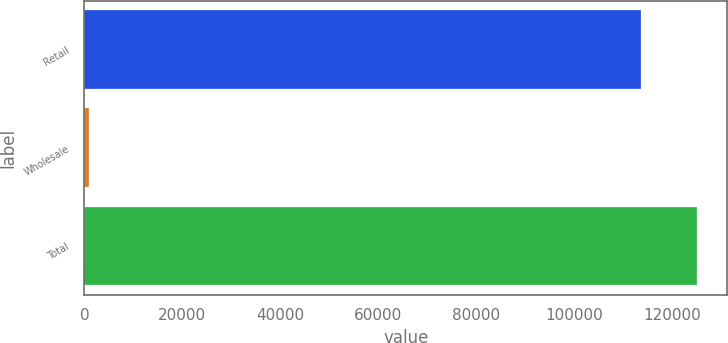Convert chart. <chart><loc_0><loc_0><loc_500><loc_500><bar_chart><fcel>Retail<fcel>Wholesale<fcel>Total<nl><fcel>113604<fcel>984<fcel>124964<nl></chart> 